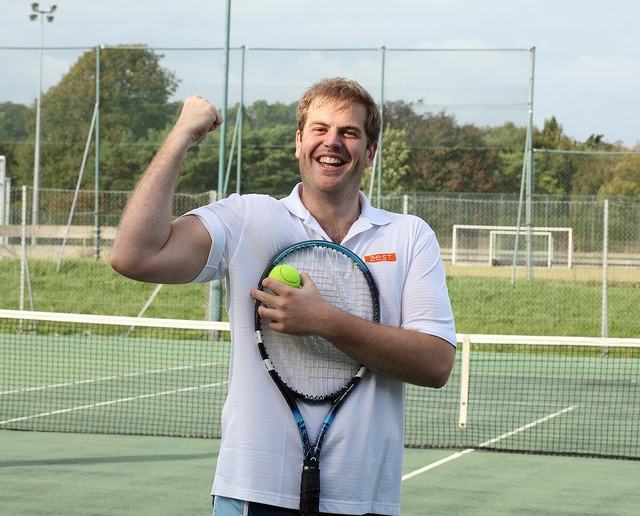Describe the objects in this image and their specific colors. I can see people in lightgray, lavender, darkgray, and gray tones, tennis racket in lightgray, darkgray, black, and gray tones, and sports ball in lightgray, lightgreen, khaki, and olive tones in this image. 